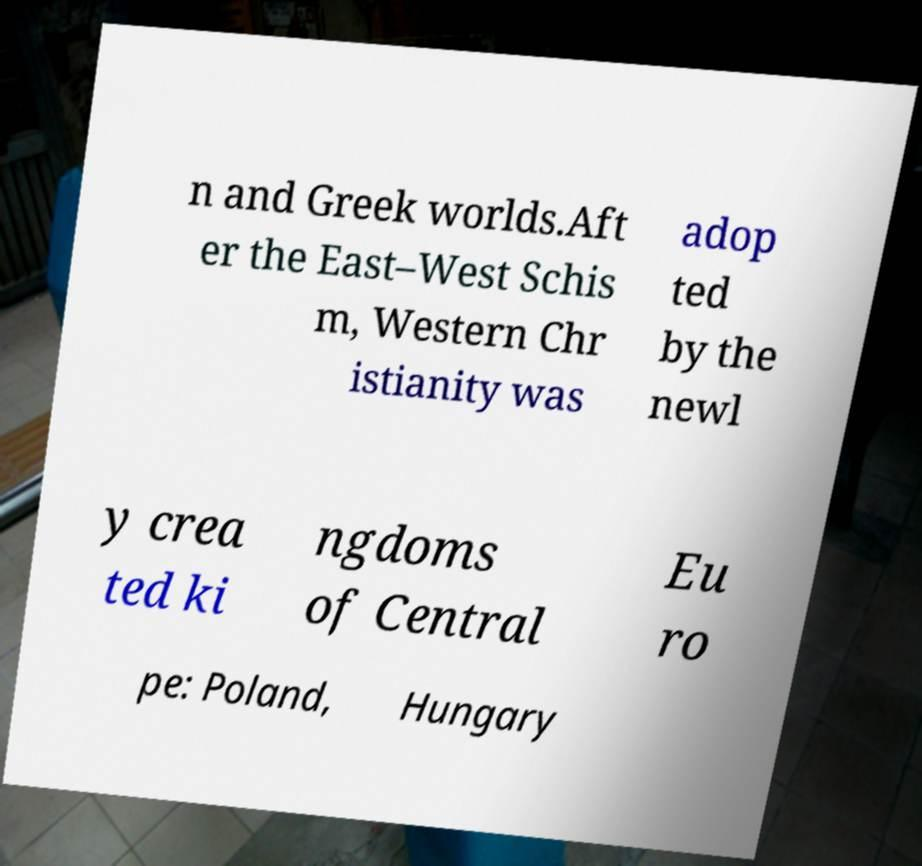Please read and relay the text visible in this image. What does it say? n and Greek worlds.Aft er the East–West Schis m, Western Chr istianity was adop ted by the newl y crea ted ki ngdoms of Central Eu ro pe: Poland, Hungary 